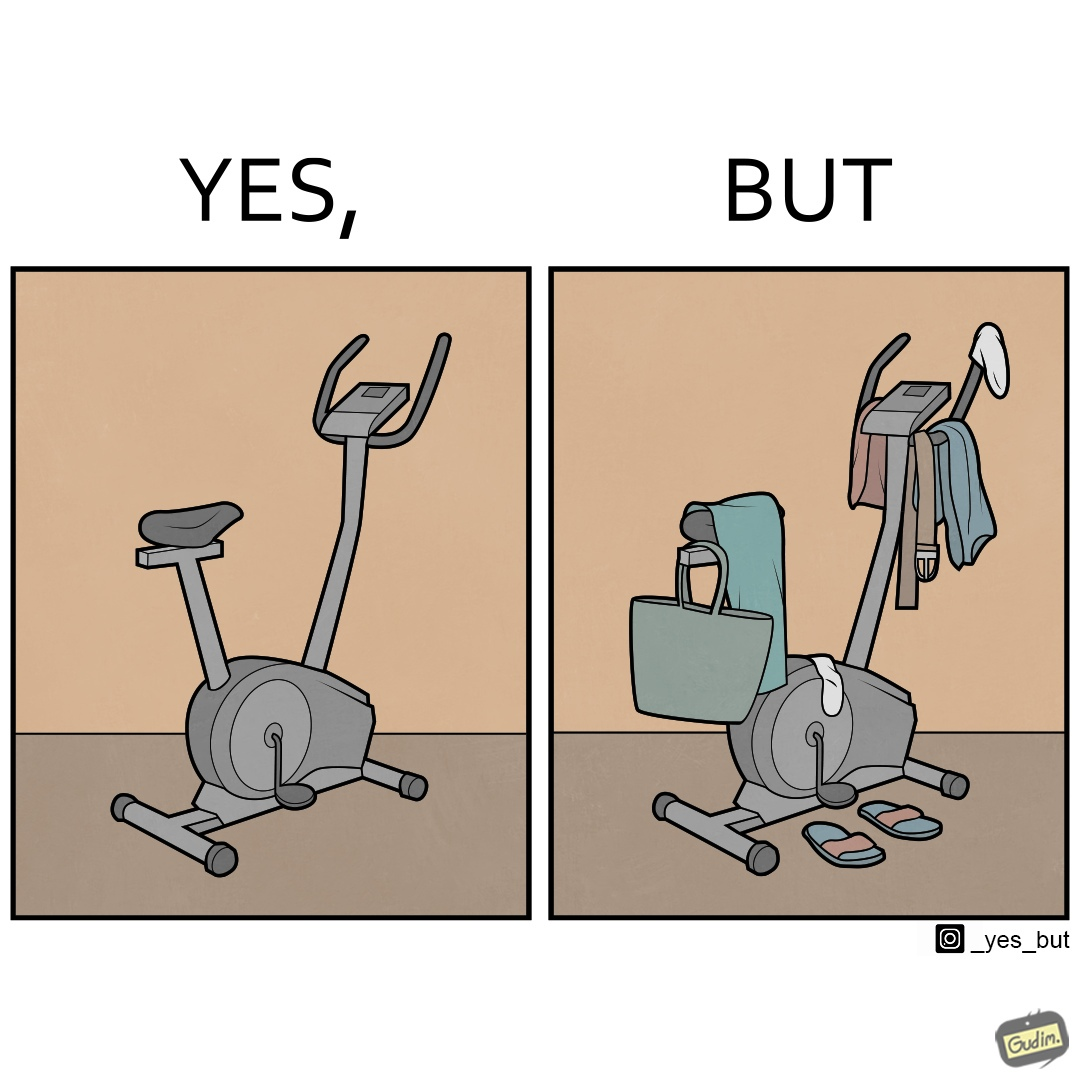Why is this image considered satirical? The images are funny since they show an exercise bike has been bought but is not being used for its purpose, that is, exercising. It is rather being used to hang clothes, bags and other items 